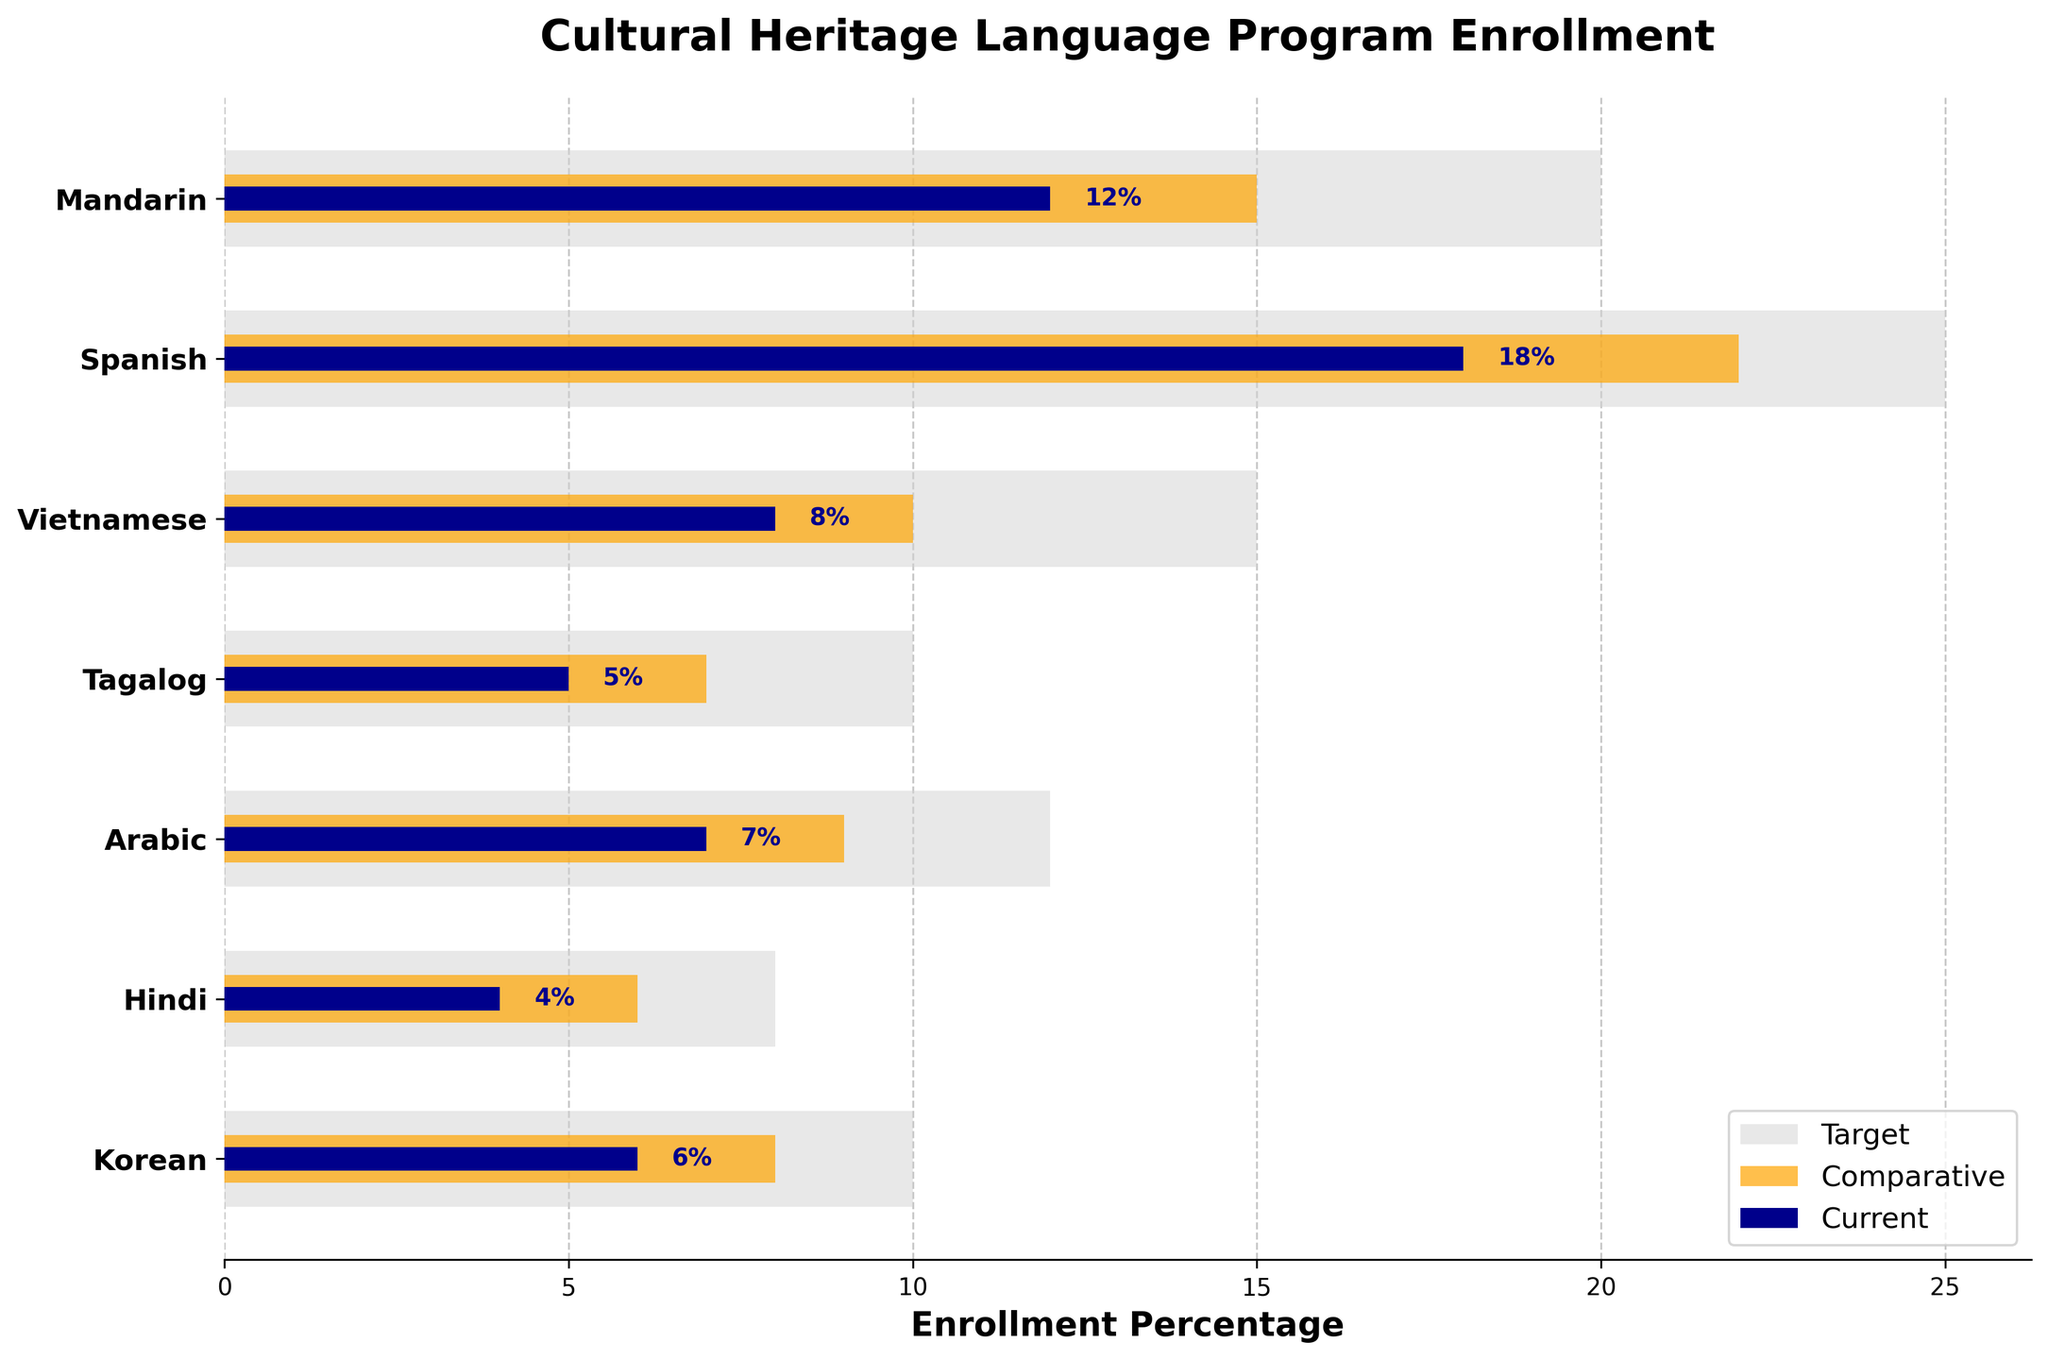What is the title of the figure? The title of the figure is displayed at the top of the plot. It usually gives a concise summary of what the plot is about.
Answer: Cultural Heritage Language Program Enrollment Which language has the lowest current enrollment percentage? To find this, look at the shortest dark blue bar, which indicates the current enrollment percentage. The language with the shortest dark blue bar has the lowest current enrollment.
Answer: Hindi How does the current enrollment percentage for Spanish compare to its comparative enrollment percentage? Look at the length of the dark blue bar for current enrollment and the orange bar for comparative enrollment. Spanish has a 18% current enrollment (dark blue) and a 22% comparative enrollment (orange).
Answer: Comparative enrollment is 4% higher Which language has the highest difference between target enrollment and current enrollment? Subtract the current enrollment (dark blue bar) from the target enrollment (light grey bar) for each language. The language with the largest difference is the one with the highest gap. For example, Mandarin's target is 20% and current is 12%, so the difference is 8%. Perform this for each language and compare.
Answer: Spanish What percentage is currently enrolled in Mandarin? Find the dark blue bar corresponding to Mandarin, and read off its length which represents the current enrollment percentage.
Answer: 12% Is there any language with current enrollment meeting or exceeding its comparative enrollment? Compare the length of the dark blue bars (current enrollment) with the orange bars (comparative enrollment) for each language. None of the dark blue bars meet or exceed their corresponding orange bars.
Answer: No What is the percentage difference between the target and comparative enrollment for Vietnamese? Subtract the comparative enrollment percentage (orange bar) from the target enrollment percentage (light grey bar) for Vietnamese. Vietnamese has a target of 15% and a comparative of 10%.
Answer: 5% How many languages have a current enrollment below 10%? Count the number of dark blue bars that are less than 10%. This is done visually by checking the lengths of the bars.
Answer: 4 Which language comes closest to meeting its target enrollment percentage without exceeding? Look at the dark blue bars (current enrollment) and compare their lengths to the light grey bars (target enrollment). The one closest without exceeding is the answer.
Answer: Spanish, with 18% current and 25% target 